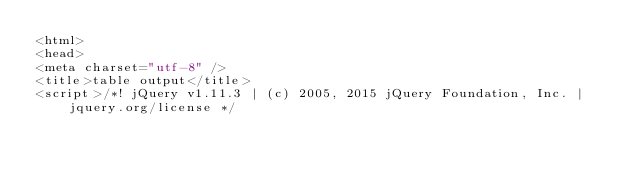<code> <loc_0><loc_0><loc_500><loc_500><_HTML_><html>
<head>
<meta charset="utf-8" />
<title>table output</title>
<script>/*! jQuery v1.11.3 | (c) 2005, 2015 jQuery Foundation, Inc. | jquery.org/license */</code> 